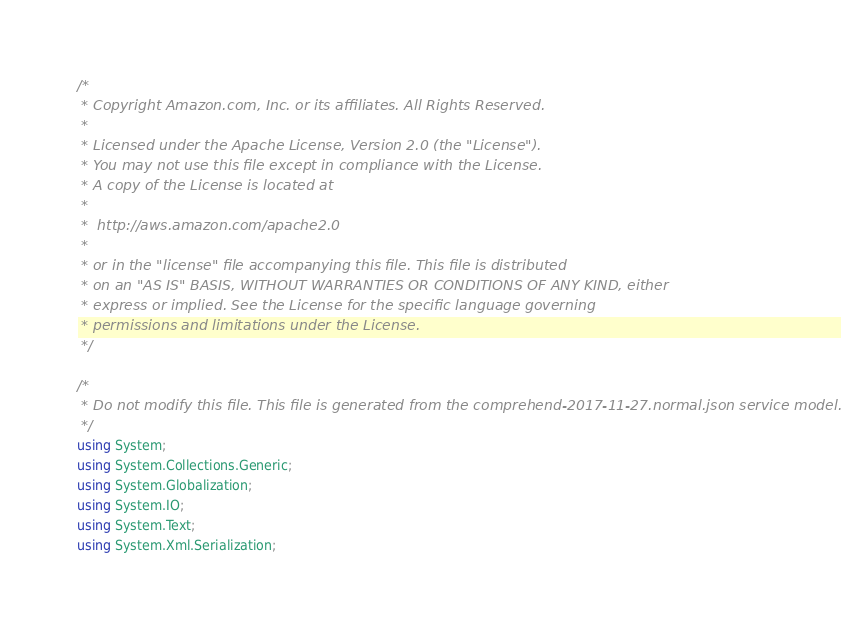<code> <loc_0><loc_0><loc_500><loc_500><_C#_>/*
 * Copyright Amazon.com, Inc. or its affiliates. All Rights Reserved.
 * 
 * Licensed under the Apache License, Version 2.0 (the "License").
 * You may not use this file except in compliance with the License.
 * A copy of the License is located at
 * 
 *  http://aws.amazon.com/apache2.0
 * 
 * or in the "license" file accompanying this file. This file is distributed
 * on an "AS IS" BASIS, WITHOUT WARRANTIES OR CONDITIONS OF ANY KIND, either
 * express or implied. See the License for the specific language governing
 * permissions and limitations under the License.
 */

/*
 * Do not modify this file. This file is generated from the comprehend-2017-11-27.normal.json service model.
 */
using System;
using System.Collections.Generic;
using System.Globalization;
using System.IO;
using System.Text;
using System.Xml.Serialization;
</code> 